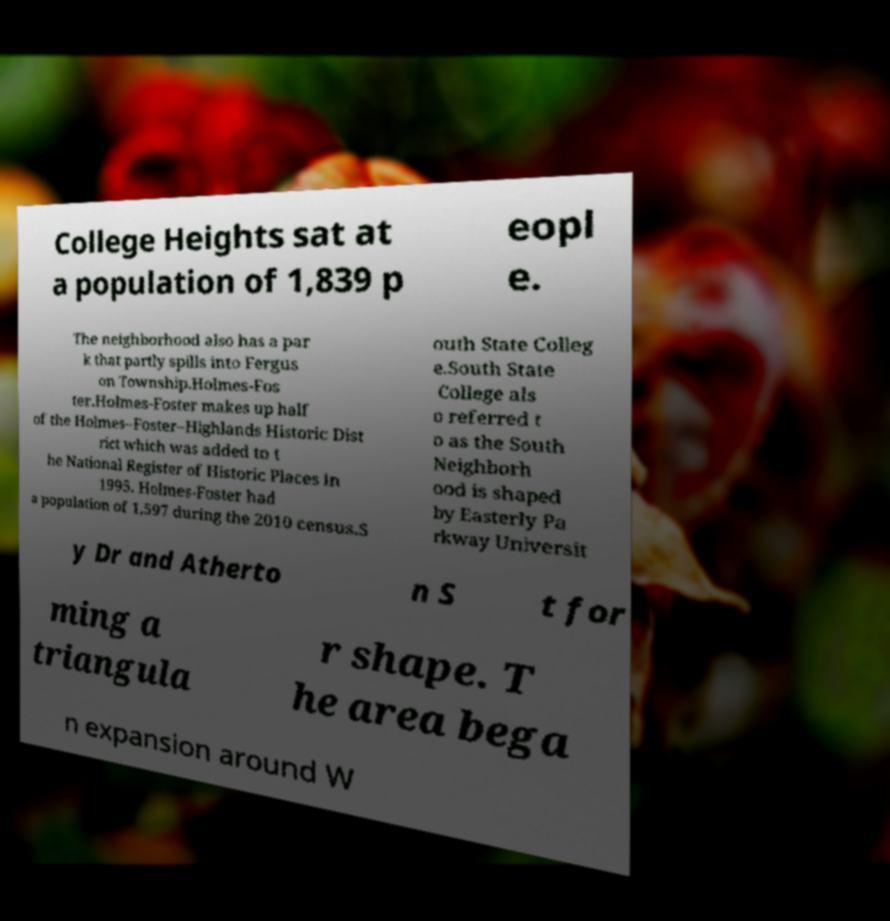For documentation purposes, I need the text within this image transcribed. Could you provide that? College Heights sat at a population of 1,839 p eopl e. The neighborhood also has a par k that partly spills into Fergus on Township.Holmes-Fos ter.Holmes-Foster makes up half of the Holmes–Foster–Highlands Historic Dist rict which was added to t he National Register of Historic Places in 1995. Holmes-Foster had a population of 1,597 during the 2010 census.S outh State Colleg e.South State College als o referred t o as the South Neighborh ood is shaped by Easterly Pa rkway Universit y Dr and Atherto n S t for ming a triangula r shape. T he area bega n expansion around W 